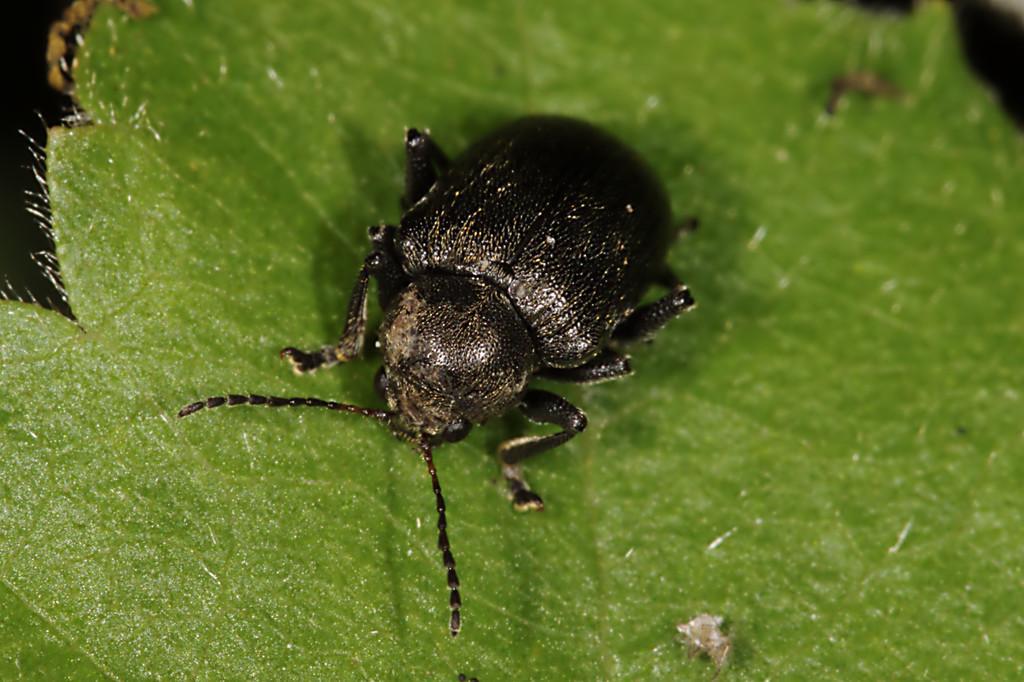Can you describe this image briefly? In this image we can see an insect on the leaf. 